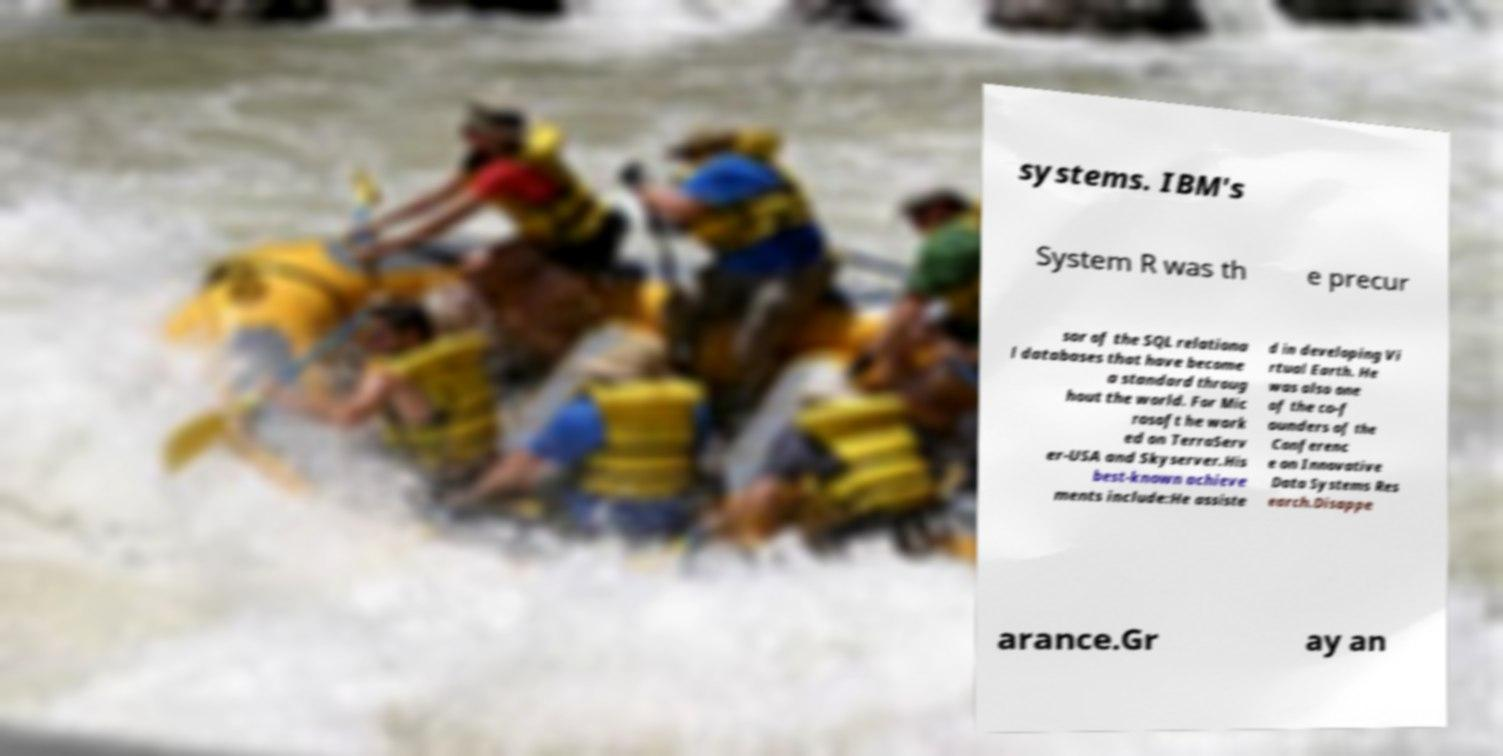Can you read and provide the text displayed in the image?This photo seems to have some interesting text. Can you extract and type it out for me? systems. IBM's System R was th e precur sor of the SQL relationa l databases that have become a standard throug hout the world. For Mic rosoft he work ed on TerraServ er-USA and Skyserver.His best-known achieve ments include:He assiste d in developing Vi rtual Earth. He was also one of the co-f ounders of the Conferenc e on Innovative Data Systems Res earch.Disappe arance.Gr ay an 